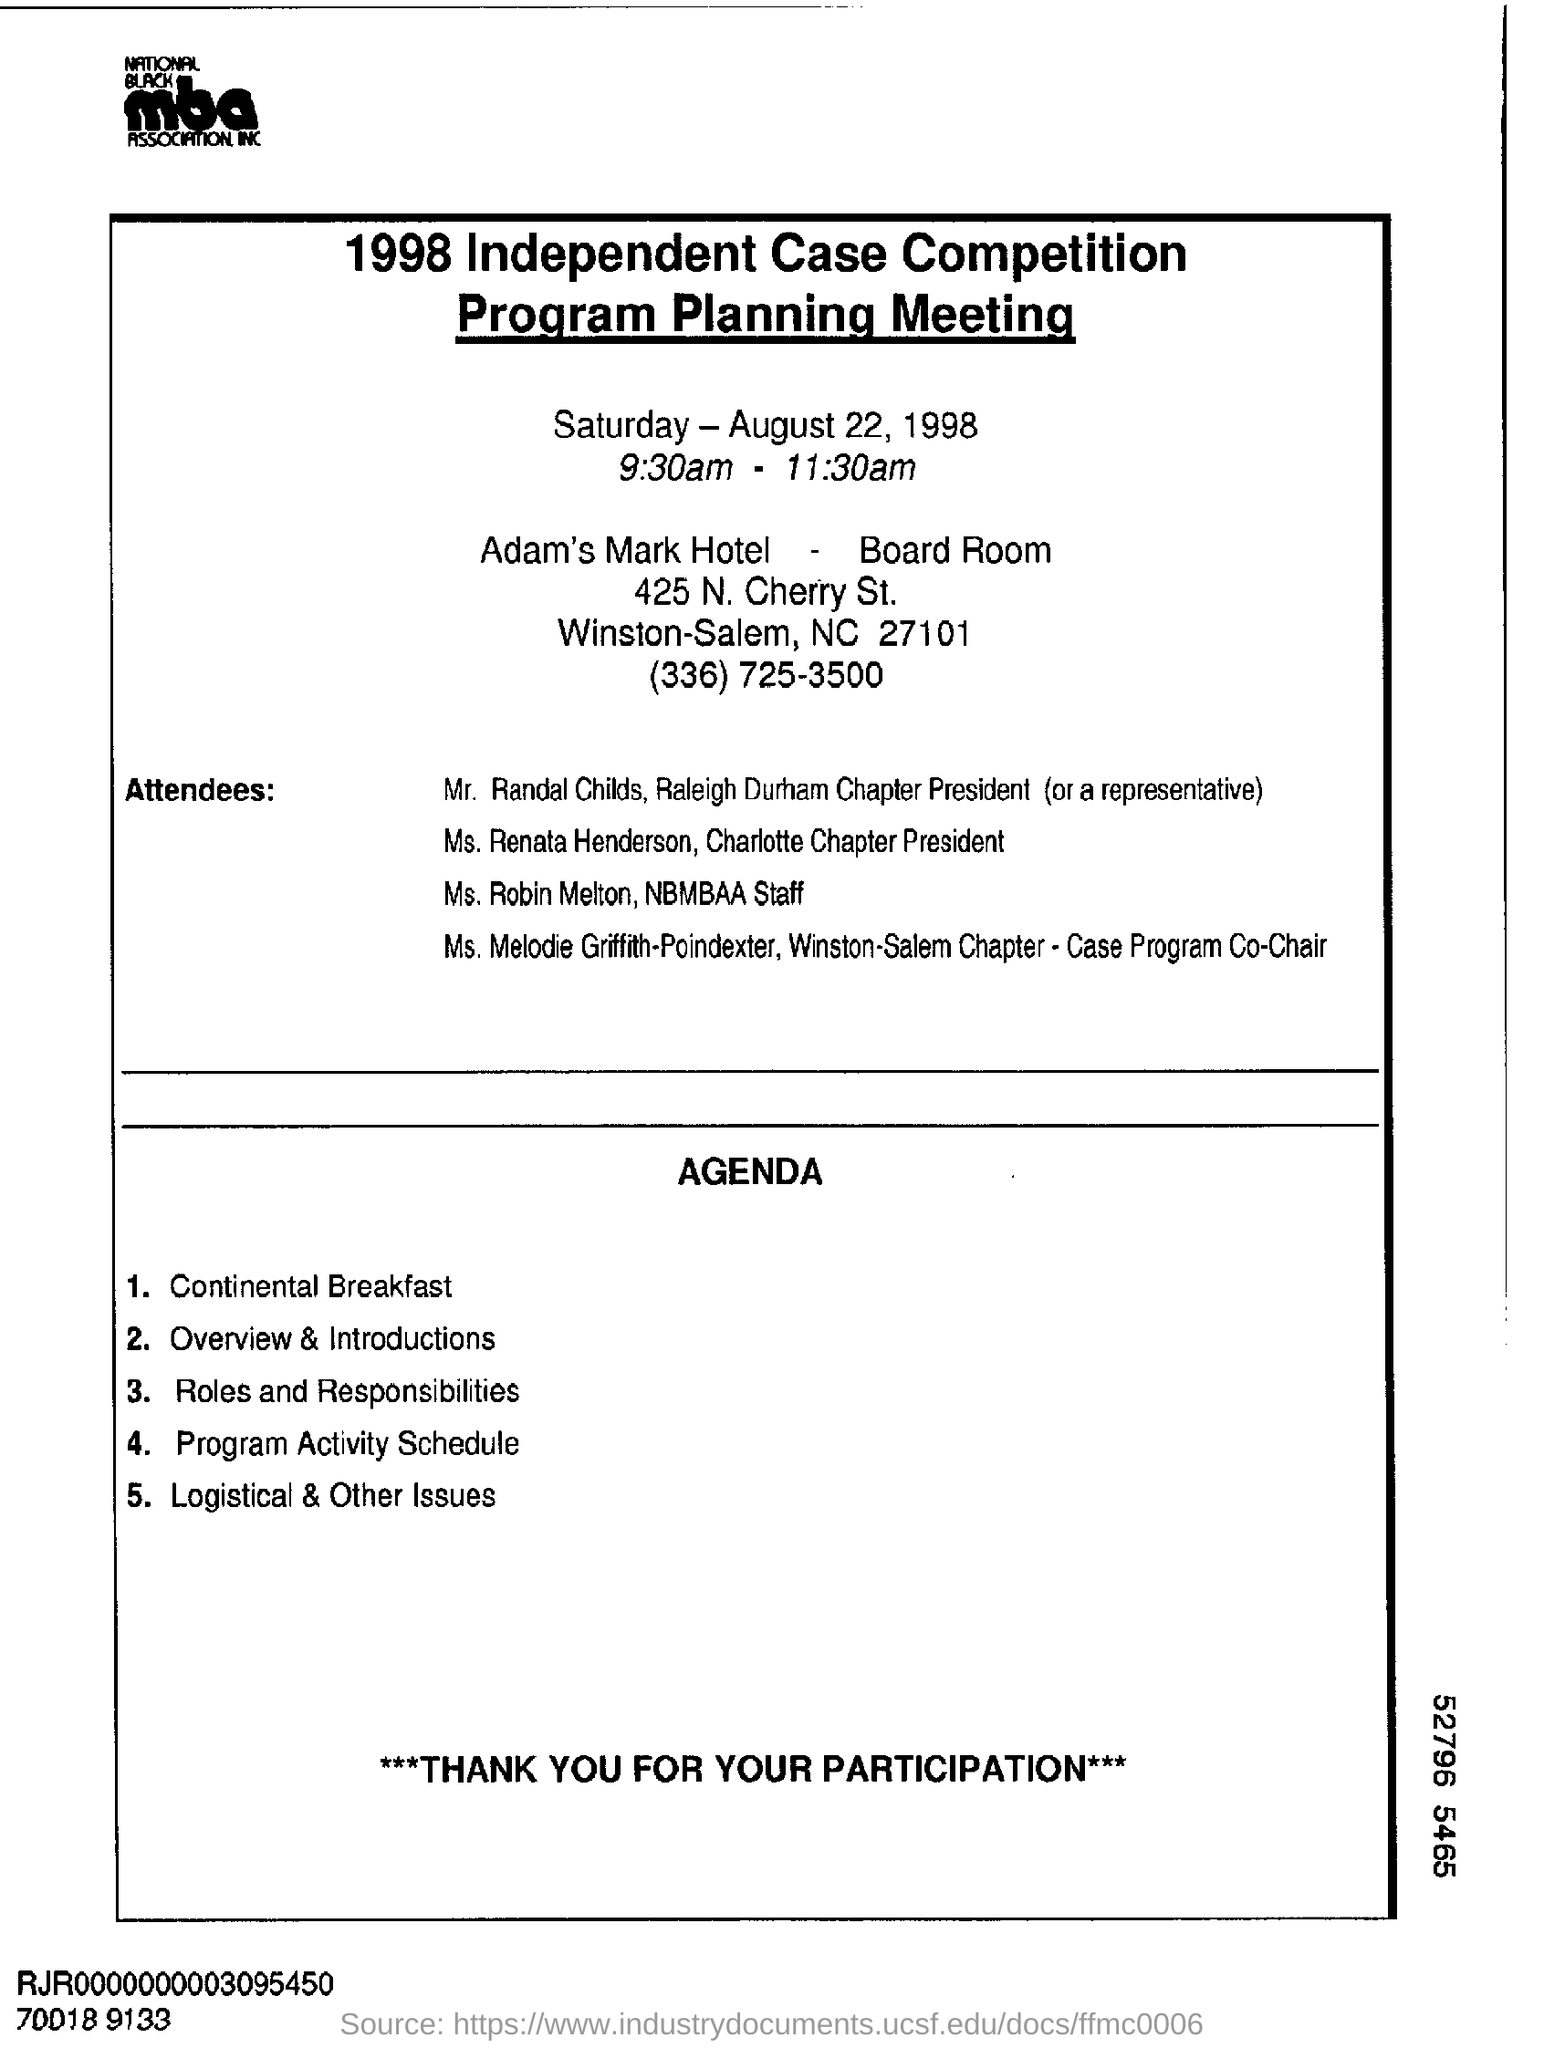List a handful of essential elements in this visual. The Program Planning Meeting is conducted from 9:30 am to 11:30 am. Ms. Renata Henderson is the president of the Charlotte chapter of an organization. The Program Planning Meeting was conducted on Saturday, August 22, 1998. 